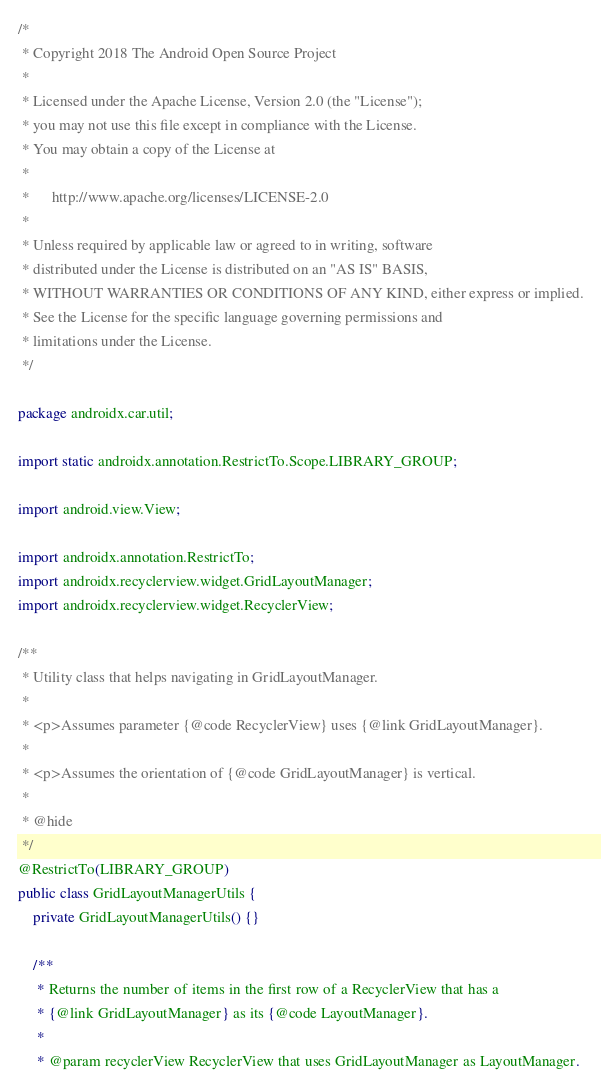<code> <loc_0><loc_0><loc_500><loc_500><_Java_>/*
 * Copyright 2018 The Android Open Source Project
 *
 * Licensed under the Apache License, Version 2.0 (the "License");
 * you may not use this file except in compliance with the License.
 * You may obtain a copy of the License at
 *
 *      http://www.apache.org/licenses/LICENSE-2.0
 *
 * Unless required by applicable law or agreed to in writing, software
 * distributed under the License is distributed on an "AS IS" BASIS,
 * WITHOUT WARRANTIES OR CONDITIONS OF ANY KIND, either express or implied.
 * See the License for the specific language governing permissions and
 * limitations under the License.
 */

package androidx.car.util;

import static androidx.annotation.RestrictTo.Scope.LIBRARY_GROUP;

import android.view.View;

import androidx.annotation.RestrictTo;
import androidx.recyclerview.widget.GridLayoutManager;
import androidx.recyclerview.widget.RecyclerView;

/**
 * Utility class that helps navigating in GridLayoutManager.
 *
 * <p>Assumes parameter {@code RecyclerView} uses {@link GridLayoutManager}.
 *
 * <p>Assumes the orientation of {@code GridLayoutManager} is vertical.
 *
 * @hide
 */
@RestrictTo(LIBRARY_GROUP)
public class GridLayoutManagerUtils {
    private GridLayoutManagerUtils() {}

    /**
     * Returns the number of items in the first row of a RecyclerView that has a
     * {@link GridLayoutManager} as its {@code LayoutManager}.
     *
     * @param recyclerView RecyclerView that uses GridLayoutManager as LayoutManager.</code> 